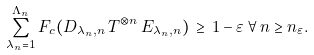Convert formula to latex. <formula><loc_0><loc_0><loc_500><loc_500>\sum _ { \lambda _ { n } = 1 } ^ { \Lambda _ { n } } F _ { c } ( D _ { \lambda _ { n } , n } \, T ^ { \otimes n } \, E _ { \lambda _ { n } , n } ) \, \geq \, 1 - \varepsilon \, \forall \, n \geq n _ { \varepsilon } .</formula> 